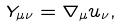Convert formula to latex. <formula><loc_0><loc_0><loc_500><loc_500>Y _ { \mu \nu } = \nabla _ { \mu } u _ { \nu } ,</formula> 